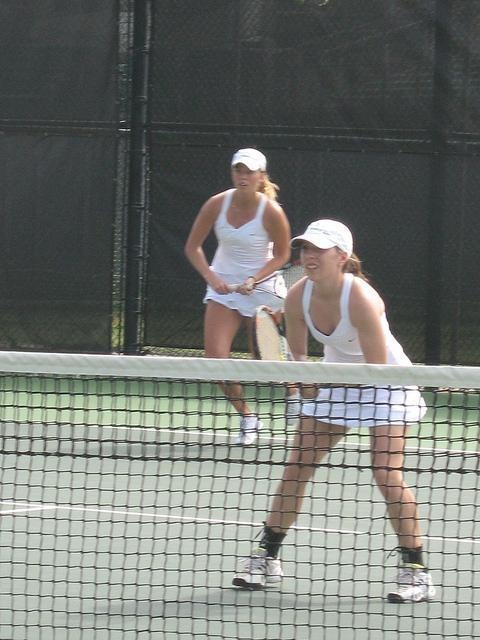How many of these players are swinging?
Give a very brief answer. 0. How many people are there?
Give a very brief answer. 2. 